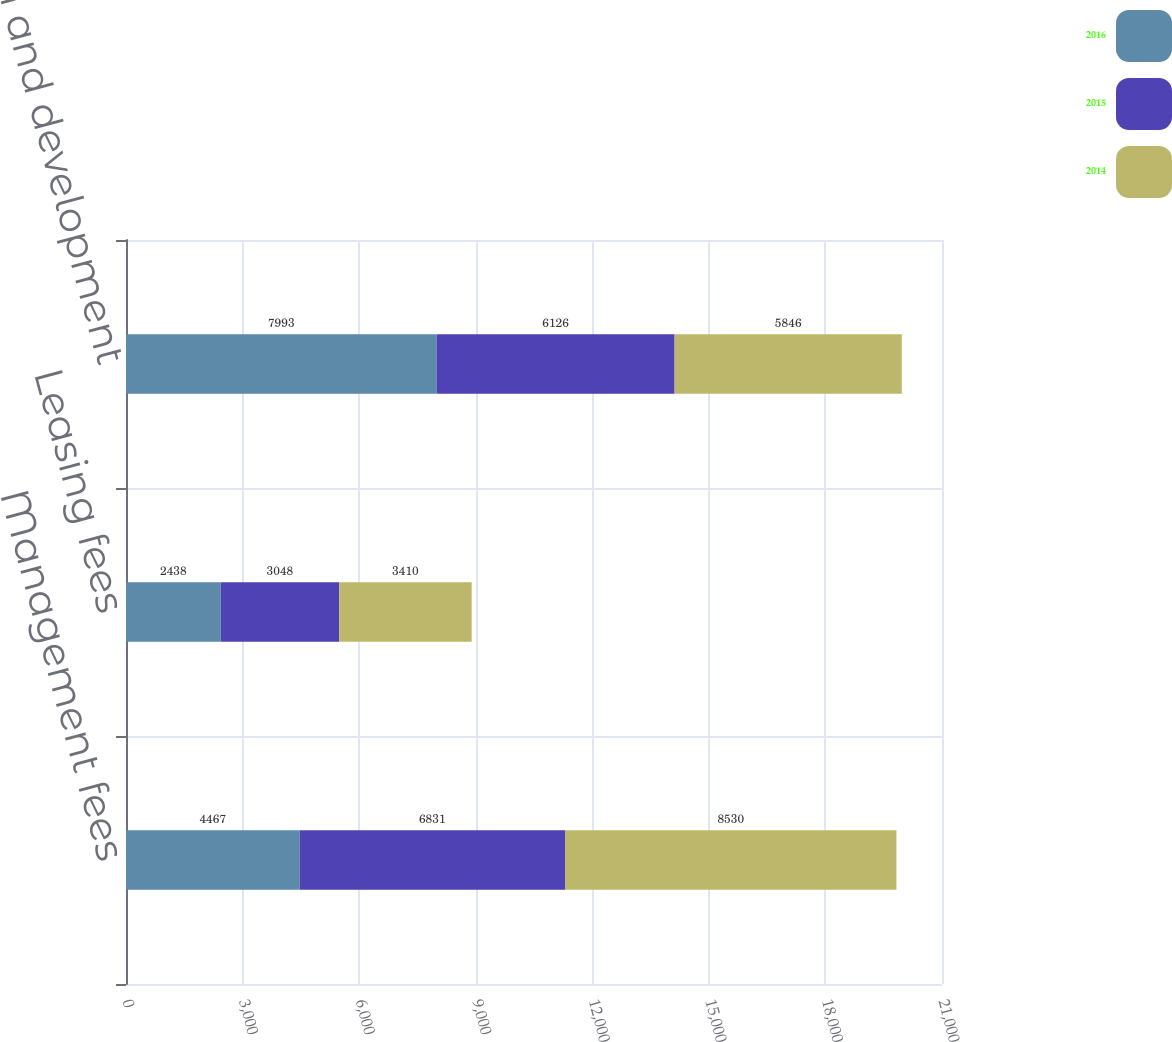<chart> <loc_0><loc_0><loc_500><loc_500><stacked_bar_chart><ecel><fcel>Management fees<fcel>Leasing fees<fcel>Construction and development<nl><fcel>2016<fcel>4467<fcel>2438<fcel>7993<nl><fcel>2015<fcel>6831<fcel>3048<fcel>6126<nl><fcel>2014<fcel>8530<fcel>3410<fcel>5846<nl></chart> 